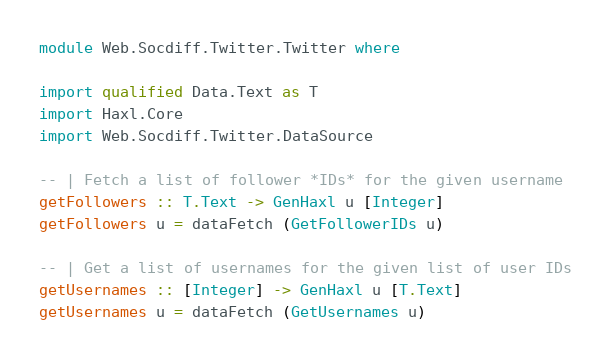<code> <loc_0><loc_0><loc_500><loc_500><_Haskell_>module Web.Socdiff.Twitter.Twitter where

import qualified Data.Text as T
import Haxl.Core
import Web.Socdiff.Twitter.DataSource

-- | Fetch a list of follower *IDs* for the given username
getFollowers :: T.Text -> GenHaxl u [Integer]
getFollowers u = dataFetch (GetFollowerIDs u)

-- | Get a list of usernames for the given list of user IDs
getUsernames :: [Integer] -> GenHaxl u [T.Text]
getUsernames u = dataFetch (GetUsernames u)
</code> 